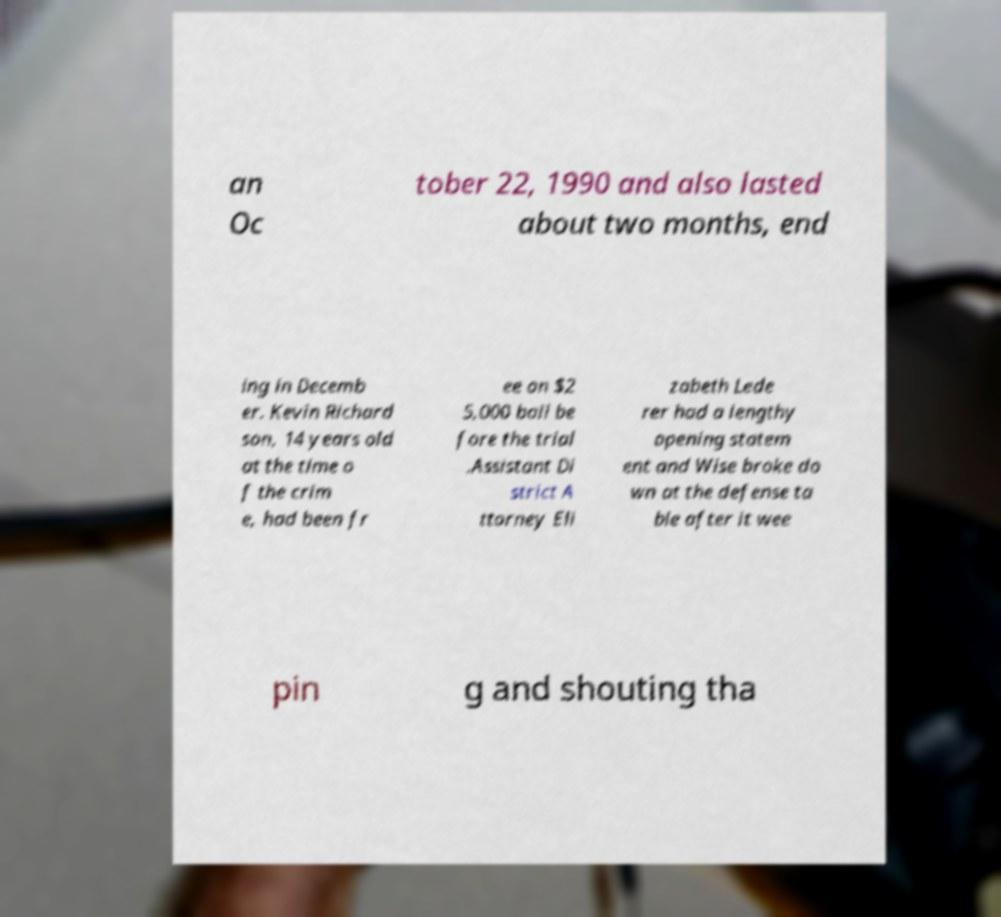Can you accurately transcribe the text from the provided image for me? an Oc tober 22, 1990 and also lasted about two months, end ing in Decemb er. Kevin Richard son, 14 years old at the time o f the crim e, had been fr ee on $2 5,000 bail be fore the trial .Assistant Di strict A ttorney Eli zabeth Lede rer had a lengthy opening statem ent and Wise broke do wn at the defense ta ble after it wee pin g and shouting tha 